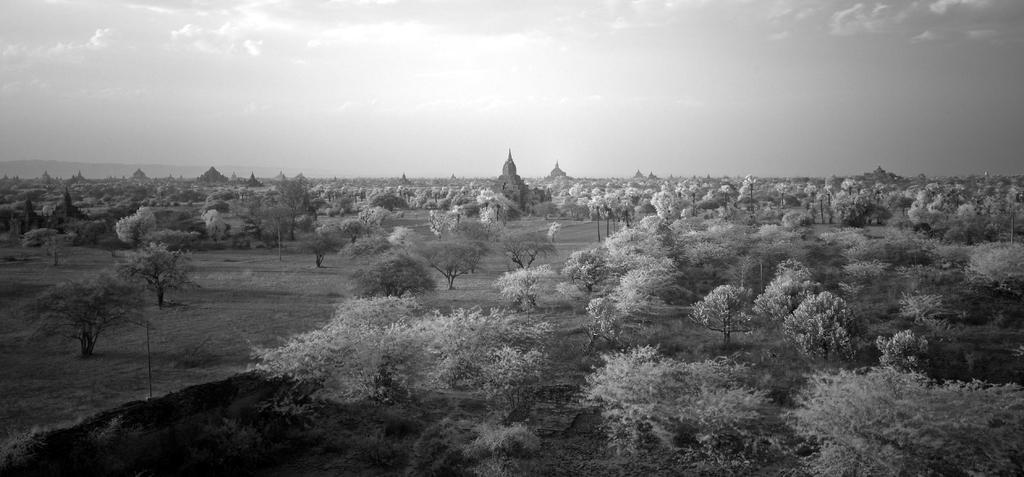How would you summarize this image in a sentence or two? This is a black and white image. In this picture we can see the buildings, trees, poles and ground. On the left side of the image we can see the hills. At the top of the image we can see the clouds in the sky. 